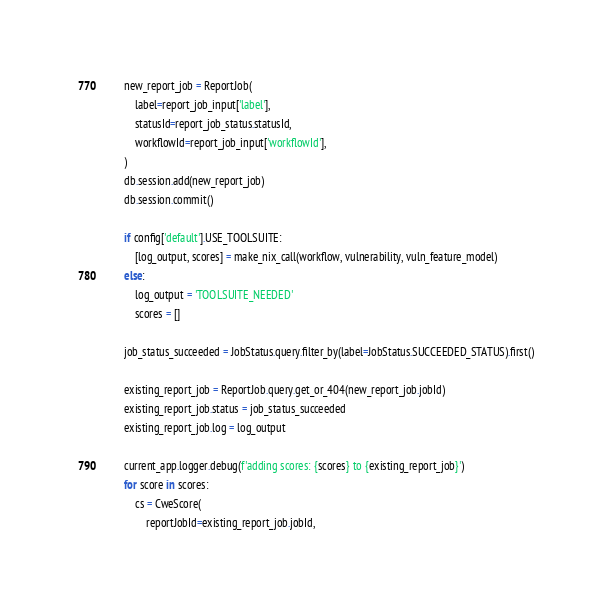Convert code to text. <code><loc_0><loc_0><loc_500><loc_500><_Python_>
        new_report_job = ReportJob(
            label=report_job_input['label'],
            statusId=report_job_status.statusId,
            workflowId=report_job_input['workflowId'],
        )
        db.session.add(new_report_job)
        db.session.commit()

        if config['default'].USE_TOOLSUITE:
            [log_output, scores] = make_nix_call(workflow, vulnerability, vuln_feature_model)
        else:
            log_output = 'TOOLSUITE_NEEDED'
            scores = []

        job_status_succeeded = JobStatus.query.filter_by(label=JobStatus.SUCCEEDED_STATUS).first()

        existing_report_job = ReportJob.query.get_or_404(new_report_job.jobId)
        existing_report_job.status = job_status_succeeded
        existing_report_job.log = log_output

        current_app.logger.debug(f'adding scores: {scores} to {existing_report_job}')
        for score in scores:
            cs = CweScore(
                reportJobId=existing_report_job.jobId,</code> 